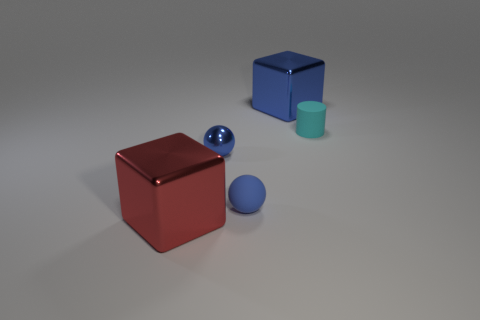What is the block behind the blue metal thing in front of the small rubber cylinder made of?
Your answer should be very brief. Metal. How many big cubes are in front of the large metallic thing that is behind the tiny matte thing that is left of the matte cylinder?
Make the answer very short. 1. Is the material of the big object left of the big blue object the same as the blue thing that is behind the tiny cyan cylinder?
Your answer should be very brief. Yes. There is another tiny sphere that is the same color as the tiny shiny ball; what is it made of?
Give a very brief answer. Rubber. How many tiny cyan matte things have the same shape as the red metallic thing?
Offer a very short reply. 0. Is the number of large red metal cubes that are left of the blue metallic cube greater than the number of big blue rubber cubes?
Ensure brevity in your answer.  Yes. What is the shape of the metal thing that is behind the tiny cyan cylinder right of the big blue object on the right side of the small blue metal ball?
Your response must be concise. Cube. Do the thing to the right of the big blue metal object and the blue metallic object that is behind the tiny cyan rubber cylinder have the same shape?
Give a very brief answer. No. What number of spheres are large purple metallic things or cyan objects?
Provide a short and direct response. 0. Are the red block and the small cylinder made of the same material?
Provide a succinct answer. No. 